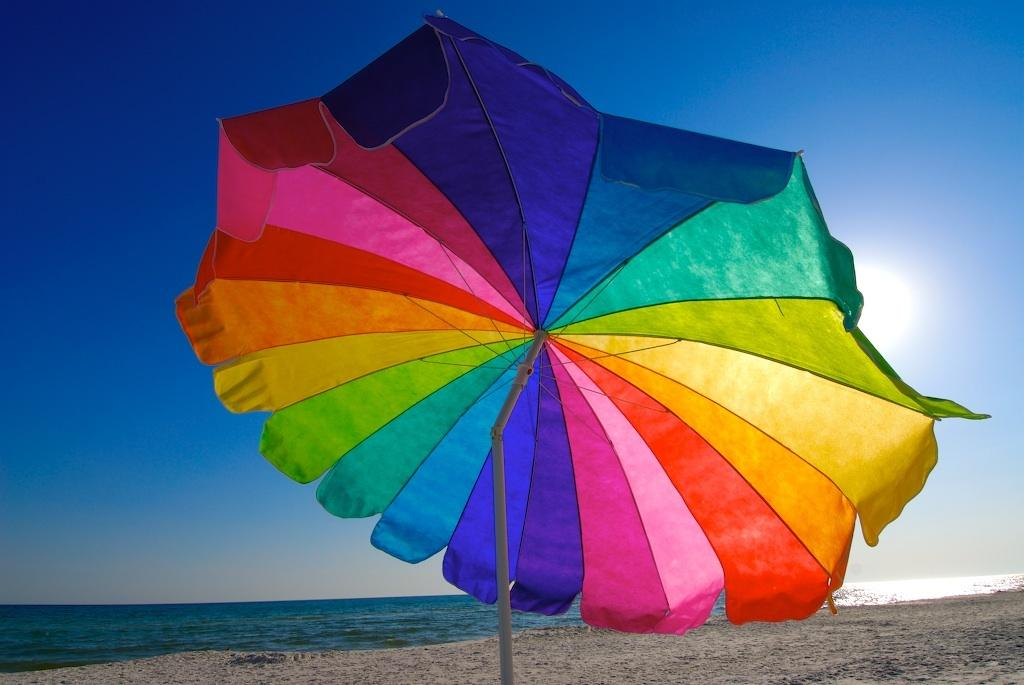What object is present in the image that can provide shade or protection from the elements? There is an umbrella in the image. Can you describe the appearance of the umbrella? The umbrella is colorful. What type of environment is depicted in the image? There is sand and water in the image, suggesting a beach or coastal setting. What is visible in the background of the image? The sky is visible in the background of the image, and the sun is observable in the sky. What type of hook can be seen attached to the umbrella in the image? There is no hook visible on the umbrella in the image. What direction is the zephyr blowing in the image? There is no mention of a zephyr or any wind in the image; it only shows an umbrella, sand, water, and the sky. 